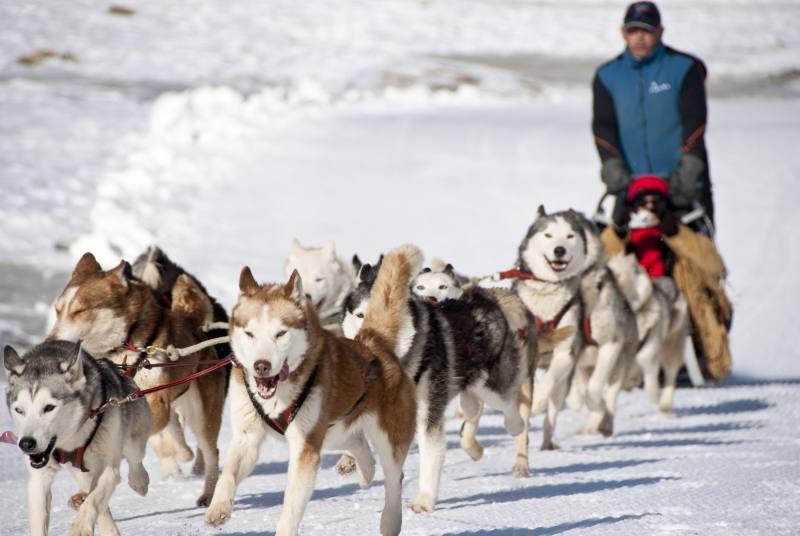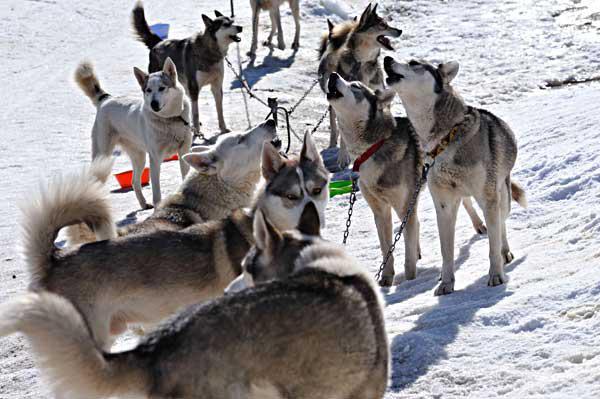The first image is the image on the left, the second image is the image on the right. For the images shown, is this caption "A person wearing a blue jacket is driving the sled." true? Answer yes or no. Yes. 